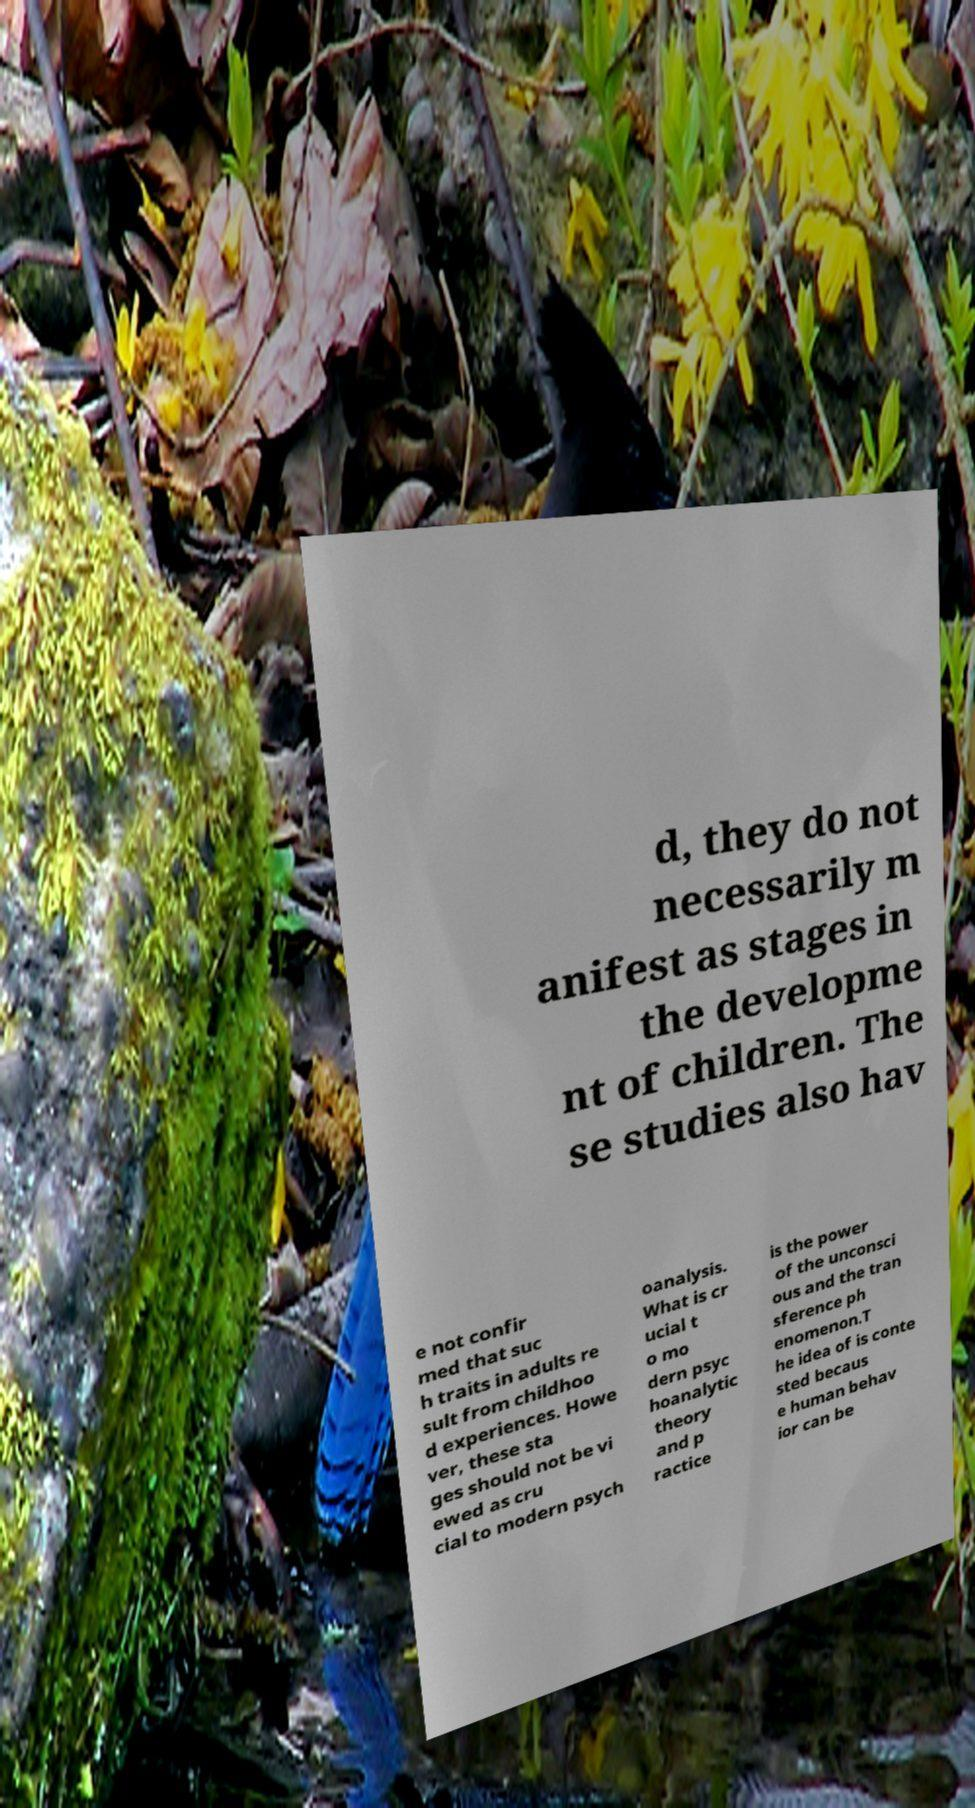I need the written content from this picture converted into text. Can you do that? d, they do not necessarily m anifest as stages in the developme nt of children. The se studies also hav e not confir med that suc h traits in adults re sult from childhoo d experiences. Howe ver, these sta ges should not be vi ewed as cru cial to modern psych oanalysis. What is cr ucial t o mo dern psyc hoanalytic theory and p ractice is the power of the unconsci ous and the tran sference ph enomenon.T he idea of is conte sted becaus e human behav ior can be 